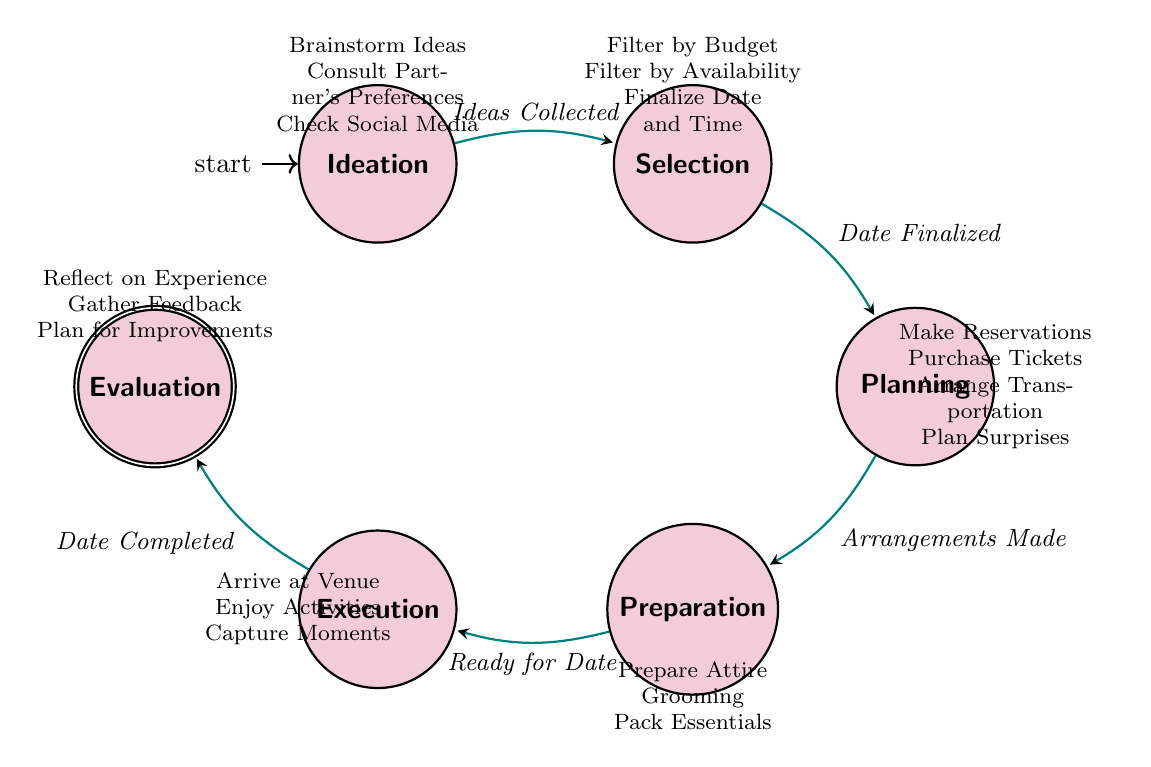What are the names of the states in the diagram? The states listed in the diagram are Ideation, Selection, Planning, Preparation, Execution, and Evaluation. These can be directly observed as the labeled nodes in the finite state machine.
Answer: Ideation, Selection, Planning, Preparation, Execution, Evaluation How many transitions are present in the diagram? The diagram shows a total of five transitions between the states, which can be counted by observing the arrows connecting the nodes.
Answer: 5 What is the condition for transitioning from Planning to Preparation? The transition from Planning to Preparation occurs under the condition "Arrangements Made." This condition is represented as an arrow labeled with this phrase in the diagram.
Answer: Arrangements Made Which state requires feedback after execution? The Evaluation state, which follows the Execution state, involves gathering feedback about the date experience as indicated in the transition labeled "Date Completed."
Answer: Evaluation What actions are involved in the Preparation state? The actions listed for the Preparation state include Prepare Attire, Grooming, and Pack Essentials, which are explicitly stated near that node in the diagram.
Answer: Prepare Attire, Grooming, Pack Essentials What is the sequence of states starting from Ideation? The sequence begins at Ideation, followed by Selection, then Planning, next Preparation, and finally ends at Execution before moving to Evaluation. This sequence can be traced through the arrows and nodes from start to finish.
Answer: Ideation, Selection, Planning, Preparation, Execution, Evaluation What is the condition that must be met to move from Ideation to Selection? The transition from Ideation to Selection requires the condition of "Ideas Collected." This is shown in the diagram as the arrow connecting these two states with the respective label.
Answer: Ideas Collected Which actions correspond to the Execution state? The Execution state encompasses the actions Arrive at Venue, Enjoy Activities, and Capture Moments, as listed in the node's action description in the diagram.
Answer: Arrive at Venue, Enjoy Activities, Capture Moments 